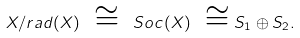<formula> <loc_0><loc_0><loc_500><loc_500>X / { r a d } ( X ) \ \cong \ { S o c } ( X ) \ \cong S _ { 1 } \oplus S _ { 2 } .</formula> 